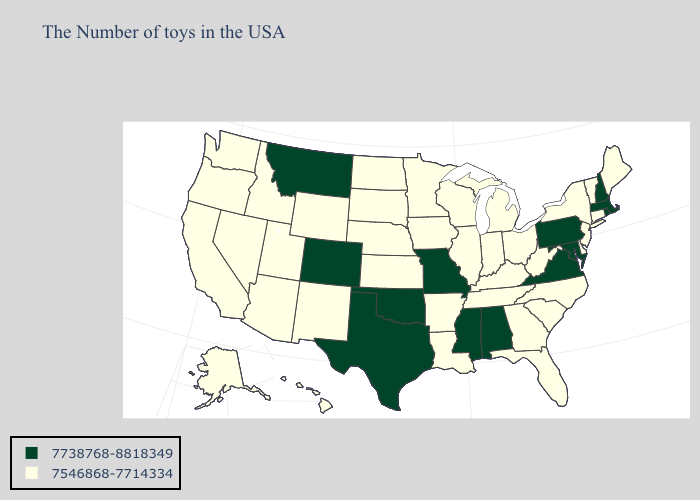Does Wisconsin have the same value as South Carolina?
Write a very short answer. Yes. Does Minnesota have the same value as Alabama?
Give a very brief answer. No. Does Texas have the highest value in the USA?
Be succinct. Yes. What is the value of Massachusetts?
Quick response, please. 7738768-8818349. Name the states that have a value in the range 7546868-7714334?
Give a very brief answer. Maine, Vermont, Connecticut, New York, New Jersey, Delaware, North Carolina, South Carolina, West Virginia, Ohio, Florida, Georgia, Michigan, Kentucky, Indiana, Tennessee, Wisconsin, Illinois, Louisiana, Arkansas, Minnesota, Iowa, Kansas, Nebraska, South Dakota, North Dakota, Wyoming, New Mexico, Utah, Arizona, Idaho, Nevada, California, Washington, Oregon, Alaska, Hawaii. Among the states that border Florida , does Georgia have the lowest value?
Be succinct. Yes. What is the lowest value in the USA?
Give a very brief answer. 7546868-7714334. Name the states that have a value in the range 7546868-7714334?
Concise answer only. Maine, Vermont, Connecticut, New York, New Jersey, Delaware, North Carolina, South Carolina, West Virginia, Ohio, Florida, Georgia, Michigan, Kentucky, Indiana, Tennessee, Wisconsin, Illinois, Louisiana, Arkansas, Minnesota, Iowa, Kansas, Nebraska, South Dakota, North Dakota, Wyoming, New Mexico, Utah, Arizona, Idaho, Nevada, California, Washington, Oregon, Alaska, Hawaii. Which states have the lowest value in the USA?
Keep it brief. Maine, Vermont, Connecticut, New York, New Jersey, Delaware, North Carolina, South Carolina, West Virginia, Ohio, Florida, Georgia, Michigan, Kentucky, Indiana, Tennessee, Wisconsin, Illinois, Louisiana, Arkansas, Minnesota, Iowa, Kansas, Nebraska, South Dakota, North Dakota, Wyoming, New Mexico, Utah, Arizona, Idaho, Nevada, California, Washington, Oregon, Alaska, Hawaii. What is the value of West Virginia?
Be succinct. 7546868-7714334. What is the value of Wisconsin?
Concise answer only. 7546868-7714334. What is the value of Wisconsin?
Quick response, please. 7546868-7714334. What is the highest value in states that border New York?
Answer briefly. 7738768-8818349. Among the states that border Utah , does Nevada have the lowest value?
Quick response, please. Yes. What is the value of Wyoming?
Keep it brief. 7546868-7714334. 